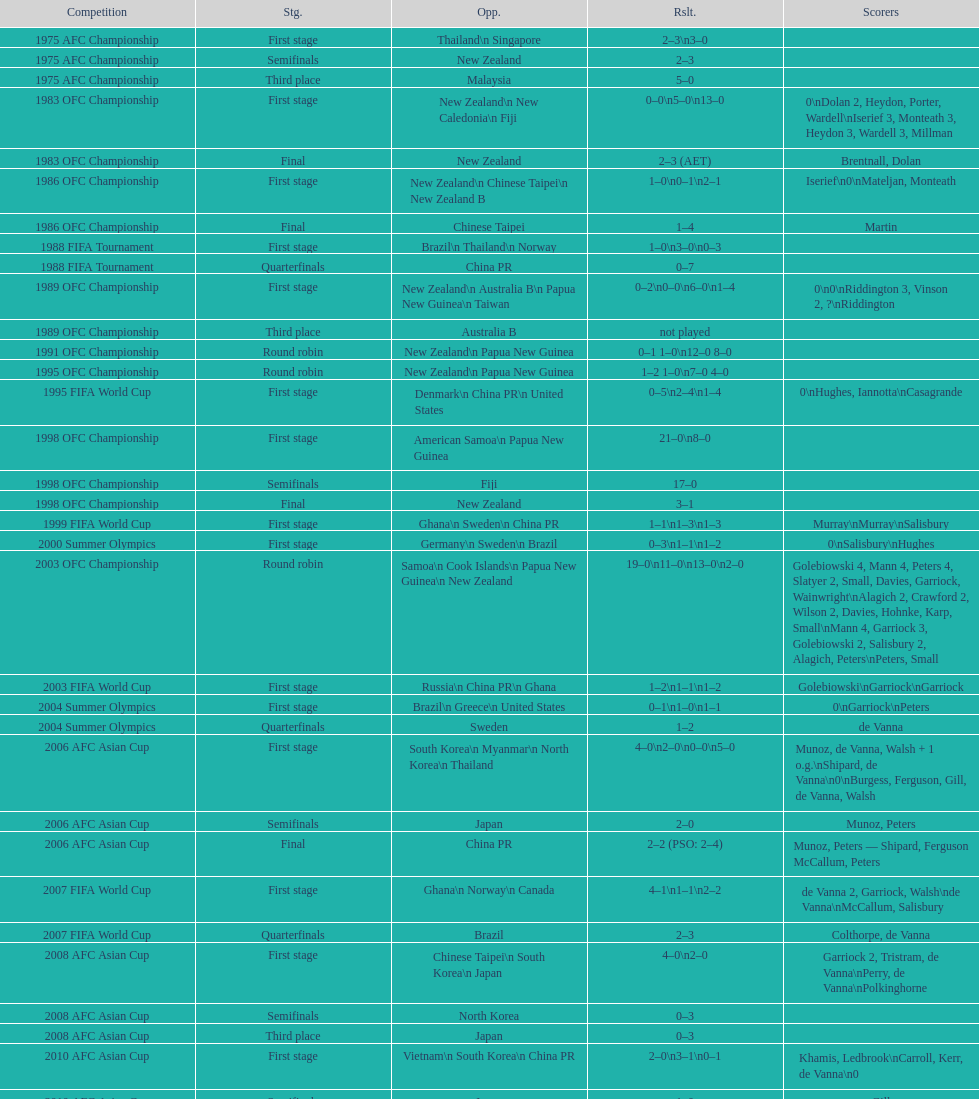Would you mind parsing the complete table? {'header': ['Competition', 'Stg.', 'Opp.', 'Rslt.', 'Scorers'], 'rows': [['1975 AFC Championship', 'First stage', 'Thailand\\n\xa0Singapore', '2–3\\n3–0', ''], ['1975 AFC Championship', 'Semifinals', 'New Zealand', '2–3', ''], ['1975 AFC Championship', 'Third place', 'Malaysia', '5–0', ''], ['1983 OFC Championship', 'First stage', 'New Zealand\\n\xa0New Caledonia\\n\xa0Fiji', '0–0\\n5–0\\n13–0', '0\\nDolan 2, Heydon, Porter, Wardell\\nIserief 3, Monteath 3, Heydon 3, Wardell 3, Millman'], ['1983 OFC Championship', 'Final', 'New Zealand', '2–3 (AET)', 'Brentnall, Dolan'], ['1986 OFC Championship', 'First stage', 'New Zealand\\n\xa0Chinese Taipei\\n New Zealand B', '1–0\\n0–1\\n2–1', 'Iserief\\n0\\nMateljan, Monteath'], ['1986 OFC Championship', 'Final', 'Chinese Taipei', '1–4', 'Martin'], ['1988 FIFA Tournament', 'First stage', 'Brazil\\n\xa0Thailand\\n\xa0Norway', '1–0\\n3–0\\n0–3', ''], ['1988 FIFA Tournament', 'Quarterfinals', 'China PR', '0–7', ''], ['1989 OFC Championship', 'First stage', 'New Zealand\\n Australia B\\n\xa0Papua New Guinea\\n\xa0Taiwan', '0–2\\n0–0\\n6–0\\n1–4', '0\\n0\\nRiddington 3, Vinson 2,\xa0?\\nRiddington'], ['1989 OFC Championship', 'Third place', 'Australia B', 'not played', ''], ['1991 OFC Championship', 'Round robin', 'New Zealand\\n\xa0Papua New Guinea', '0–1 1–0\\n12–0 8–0', ''], ['1995 OFC Championship', 'Round robin', 'New Zealand\\n\xa0Papua New Guinea', '1–2 1–0\\n7–0 4–0', ''], ['1995 FIFA World Cup', 'First stage', 'Denmark\\n\xa0China PR\\n\xa0United States', '0–5\\n2–4\\n1–4', '0\\nHughes, Iannotta\\nCasagrande'], ['1998 OFC Championship', 'First stage', 'American Samoa\\n\xa0Papua New Guinea', '21–0\\n8–0', ''], ['1998 OFC Championship', 'Semifinals', 'Fiji', '17–0', ''], ['1998 OFC Championship', 'Final', 'New Zealand', '3–1', ''], ['1999 FIFA World Cup', 'First stage', 'Ghana\\n\xa0Sweden\\n\xa0China PR', '1–1\\n1–3\\n1–3', 'Murray\\nMurray\\nSalisbury'], ['2000 Summer Olympics', 'First stage', 'Germany\\n\xa0Sweden\\n\xa0Brazil', '0–3\\n1–1\\n1–2', '0\\nSalisbury\\nHughes'], ['2003 OFC Championship', 'Round robin', 'Samoa\\n\xa0Cook Islands\\n\xa0Papua New Guinea\\n\xa0New Zealand', '19–0\\n11–0\\n13–0\\n2–0', 'Golebiowski 4, Mann 4, Peters 4, Slatyer 2, Small, Davies, Garriock, Wainwright\\nAlagich 2, Crawford 2, Wilson 2, Davies, Hohnke, Karp, Small\\nMann 4, Garriock 3, Golebiowski 2, Salisbury 2, Alagich, Peters\\nPeters, Small'], ['2003 FIFA World Cup', 'First stage', 'Russia\\n\xa0China PR\\n\xa0Ghana', '1–2\\n1–1\\n1–2', 'Golebiowski\\nGarriock\\nGarriock'], ['2004 Summer Olympics', 'First stage', 'Brazil\\n\xa0Greece\\n\xa0United States', '0–1\\n1–0\\n1–1', '0\\nGarriock\\nPeters'], ['2004 Summer Olympics', 'Quarterfinals', 'Sweden', '1–2', 'de Vanna'], ['2006 AFC Asian Cup', 'First stage', 'South Korea\\n\xa0Myanmar\\n\xa0North Korea\\n\xa0Thailand', '4–0\\n2–0\\n0–0\\n5–0', 'Munoz, de Vanna, Walsh + 1 o.g.\\nShipard, de Vanna\\n0\\nBurgess, Ferguson, Gill, de Vanna, Walsh'], ['2006 AFC Asian Cup', 'Semifinals', 'Japan', '2–0', 'Munoz, Peters'], ['2006 AFC Asian Cup', 'Final', 'China PR', '2–2 (PSO: 2–4)', 'Munoz, Peters — Shipard, Ferguson McCallum, Peters'], ['2007 FIFA World Cup', 'First stage', 'Ghana\\n\xa0Norway\\n\xa0Canada', '4–1\\n1–1\\n2–2', 'de Vanna 2, Garriock, Walsh\\nde Vanna\\nMcCallum, Salisbury'], ['2007 FIFA World Cup', 'Quarterfinals', 'Brazil', '2–3', 'Colthorpe, de Vanna'], ['2008 AFC Asian Cup', 'First stage', 'Chinese Taipei\\n\xa0South Korea\\n\xa0Japan', '4–0\\n2–0', 'Garriock 2, Tristram, de Vanna\\nPerry, de Vanna\\nPolkinghorne'], ['2008 AFC Asian Cup', 'Semifinals', 'North Korea', '0–3', ''], ['2008 AFC Asian Cup', 'Third place', 'Japan', '0–3', ''], ['2010 AFC Asian Cup', 'First stage', 'Vietnam\\n\xa0South Korea\\n\xa0China PR', '2–0\\n3–1\\n0–1', 'Khamis, Ledbrook\\nCarroll, Kerr, de Vanna\\n0'], ['2010 AFC Asian Cup', 'Semifinals', 'Japan', '1–0', 'Gill'], ['2010 AFC Asian Cup', 'Final', 'North Korea', '1–1 (PSO: 5–4)', 'Kerr — PSO: Shipard, Ledbrook, Gill, Garriock, Simon'], ['2011 FIFA World Cup', 'First stage', 'Brazil\\n\xa0Equatorial Guinea\\n\xa0Norway', '0–1\\n3–2\\n2–1', '0\\nvan Egmond, Khamis, de Vanna\\nSimon 2'], ['2011 FIFA World Cup', 'Quarterfinals', 'Sweden', '1–3', 'Perry'], ['2012 Summer Olympics\\nAFC qualification', 'Final round', 'North Korea\\n\xa0Thailand\\n\xa0Japan\\n\xa0China PR\\n\xa0South Korea', '0–1\\n5–1\\n0–1\\n1–0\\n2–1', '0\\nHeyman 2, Butt, van Egmond, Simon\\n0\\nvan Egmond\\nButt, de Vanna'], ['2014 AFC Asian Cup', 'First stage', 'Japan\\n\xa0Jordan\\n\xa0Vietnam', 'TBD\\nTBD\\nTBD', '']]} Who was the last opponent this team faced in the 2010 afc asian cup? North Korea. 